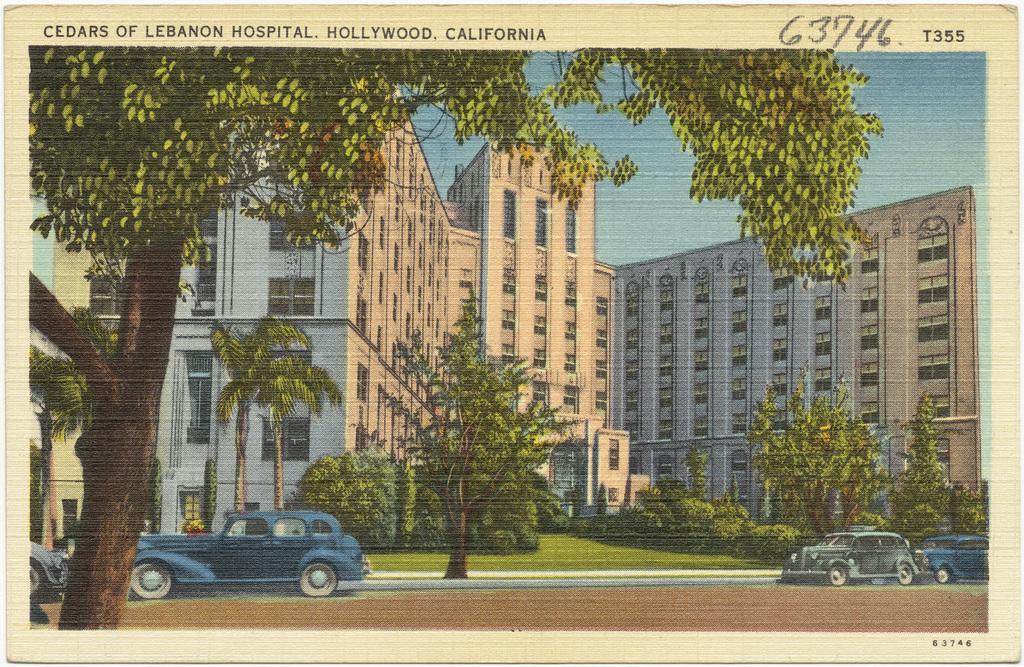Describe this image in one or two sentences. This is a painting of an image as we can see there are some vehicles in the bottom of this image and there are some trees in the background. There are some buildings in middle of this image and there is a sky on the top of this image. 